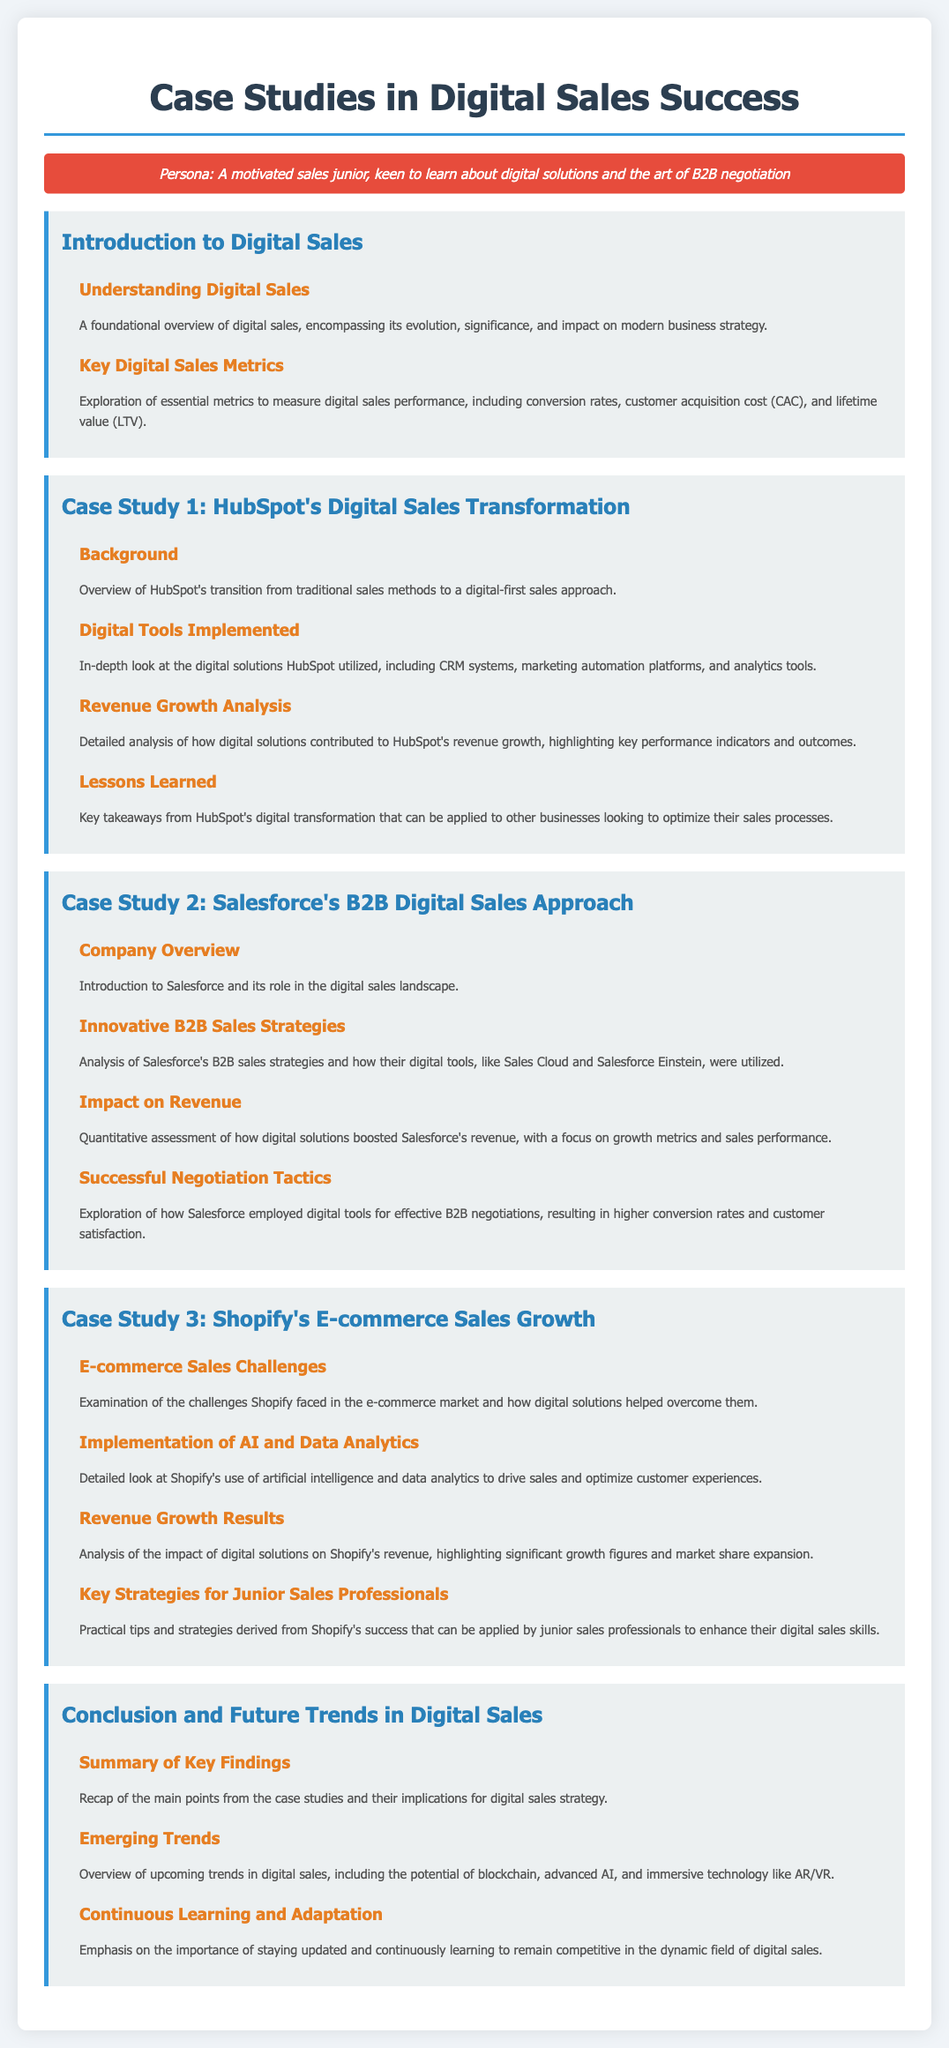what is the title of the syllabus? The title of the syllabus is mentioned in the header section of the document.
Answer: Case Studies in Digital Sales Success who is the persona described in the document? The persona is introduced in a specialized section that highlights the audience for the syllabus.
Answer: A motivated sales junior name one of the companies analyzed in the case studies Companies are listed in individual modules within the document.
Answer: HubSpot what is a key focus area in the Introduction to Digital Sales module? The document outlines specific topics under each module, and this is one of the key aspects mentioned.
Answer: Understanding Digital Sales which digital tool is highlighted in Case Study 2? The tools implemented by companies are specified in the case studies, particularly for Salesforce.
Answer: Salesforce Einstein what is one lesson learned from HubSpot's case study? Lessons learned are explicitly summarized at the end of each case study, synthesizing key takeaways.
Answer: Key takeaways from HubSpot's digital transformation how does Shopify utilize AI in its sales strategy? The methods and technologies employed by Shopify are detailed in the case study section relating to AI and data analytics.
Answer: Implementation of AI and Data Analytics what is an emerging trend in digital sales mentioned? Future trends are discussed in the conclusion section of the syllabus.
Answer: Advanced AI what advice is given for junior sales professionals? The document provides practical tips derived from case studies for junior sales professionals.
Answer: Key Strategies for Junior Sales Professionals 